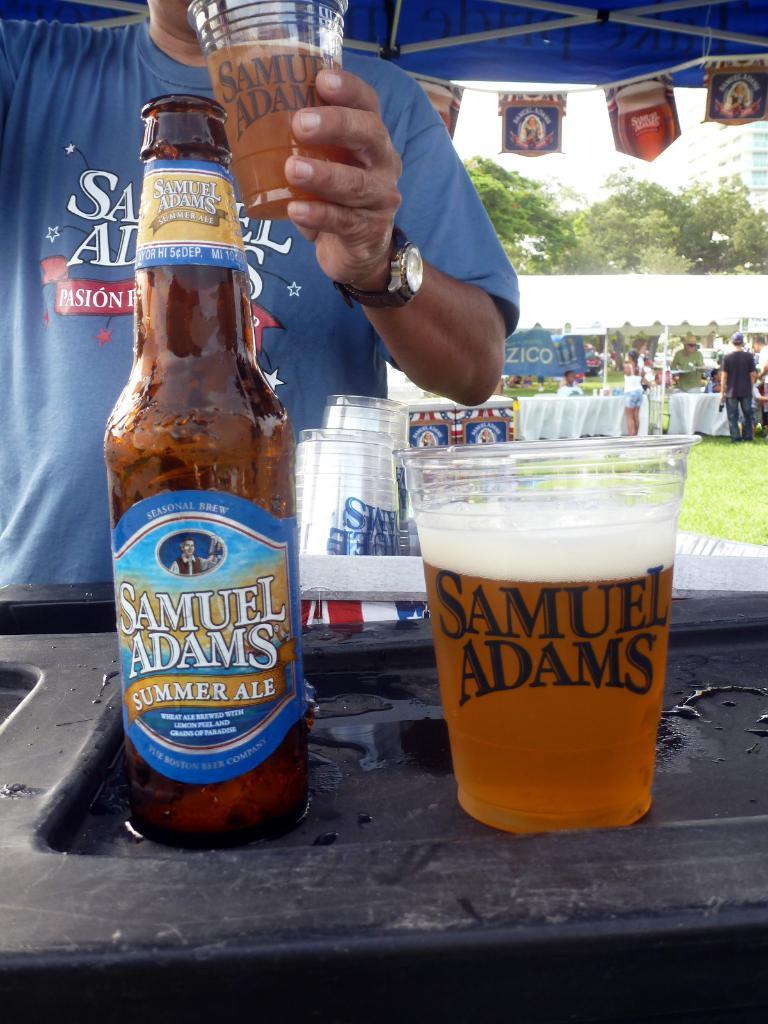What famous beer brewer is shown on both the bottle and the cup?
Your response must be concise. Samuel adams. Which beer is displayed?
Your answer should be compact. Samuel adams. 